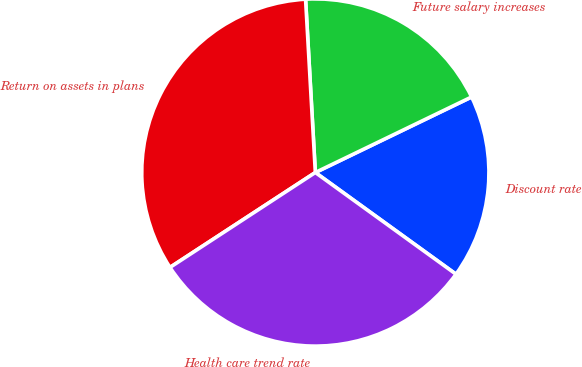Convert chart. <chart><loc_0><loc_0><loc_500><loc_500><pie_chart><fcel>Discount rate<fcel>Future salary increases<fcel>Return on assets in plans<fcel>Health care trend rate<nl><fcel>17.13%<fcel>18.73%<fcel>33.31%<fcel>30.83%<nl></chart> 